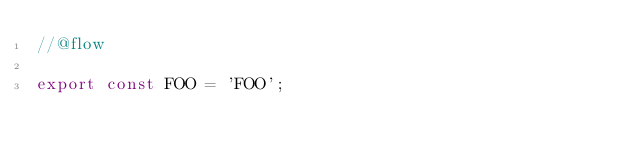<code> <loc_0><loc_0><loc_500><loc_500><_JavaScript_>//@flow

export const FOO = 'FOO';
</code> 